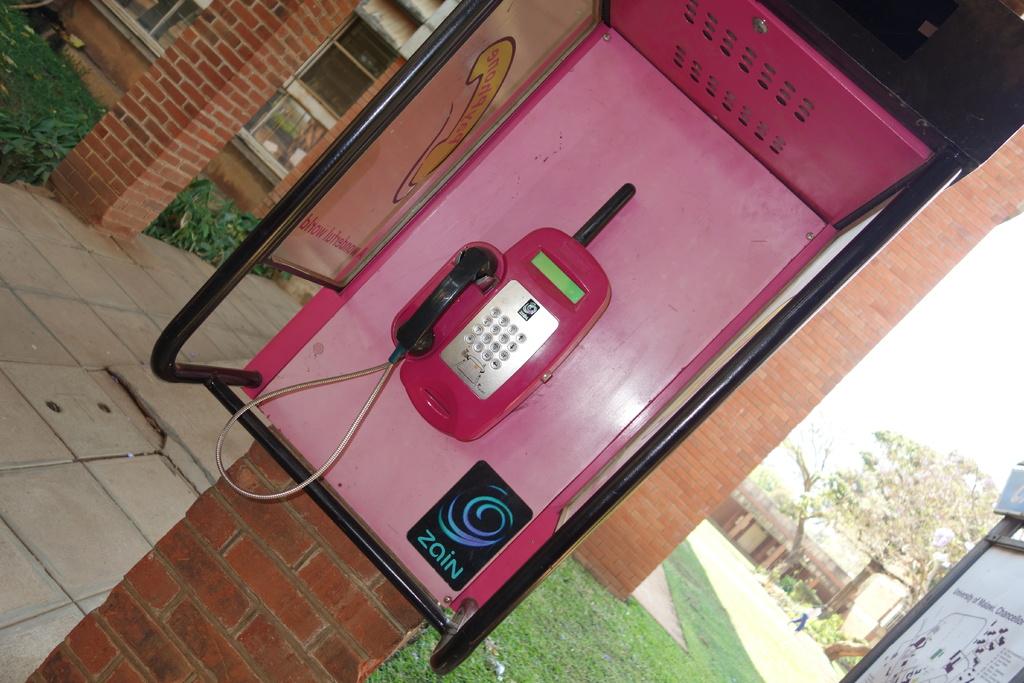Is zain the phone company?
Keep it short and to the point. Yes. What company logo is posted next to the phone?
Your answer should be very brief. Zain. 